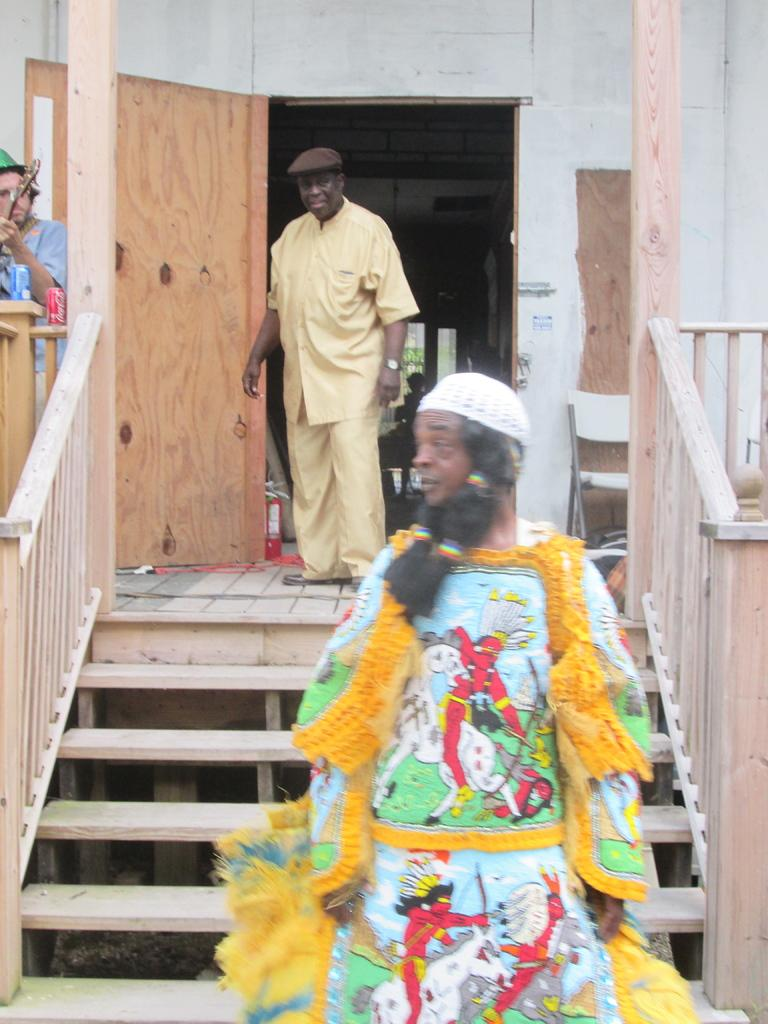How many people are in the image? There are three persons in the image. What can be seen in the background of the image? There is a wall in the background of the image. What architectural feature is present in the image? There are stairs in the image. Is there an entrance or exit visible in the image? Yes, there is a door in the image. What is one person wearing in the image? One person in the image is wearing a cap. How many kittens are playing with marbles on the stairs in the image? There are no kittens or marbles present in the image; it features three persons and a door, wall, and stairs. 